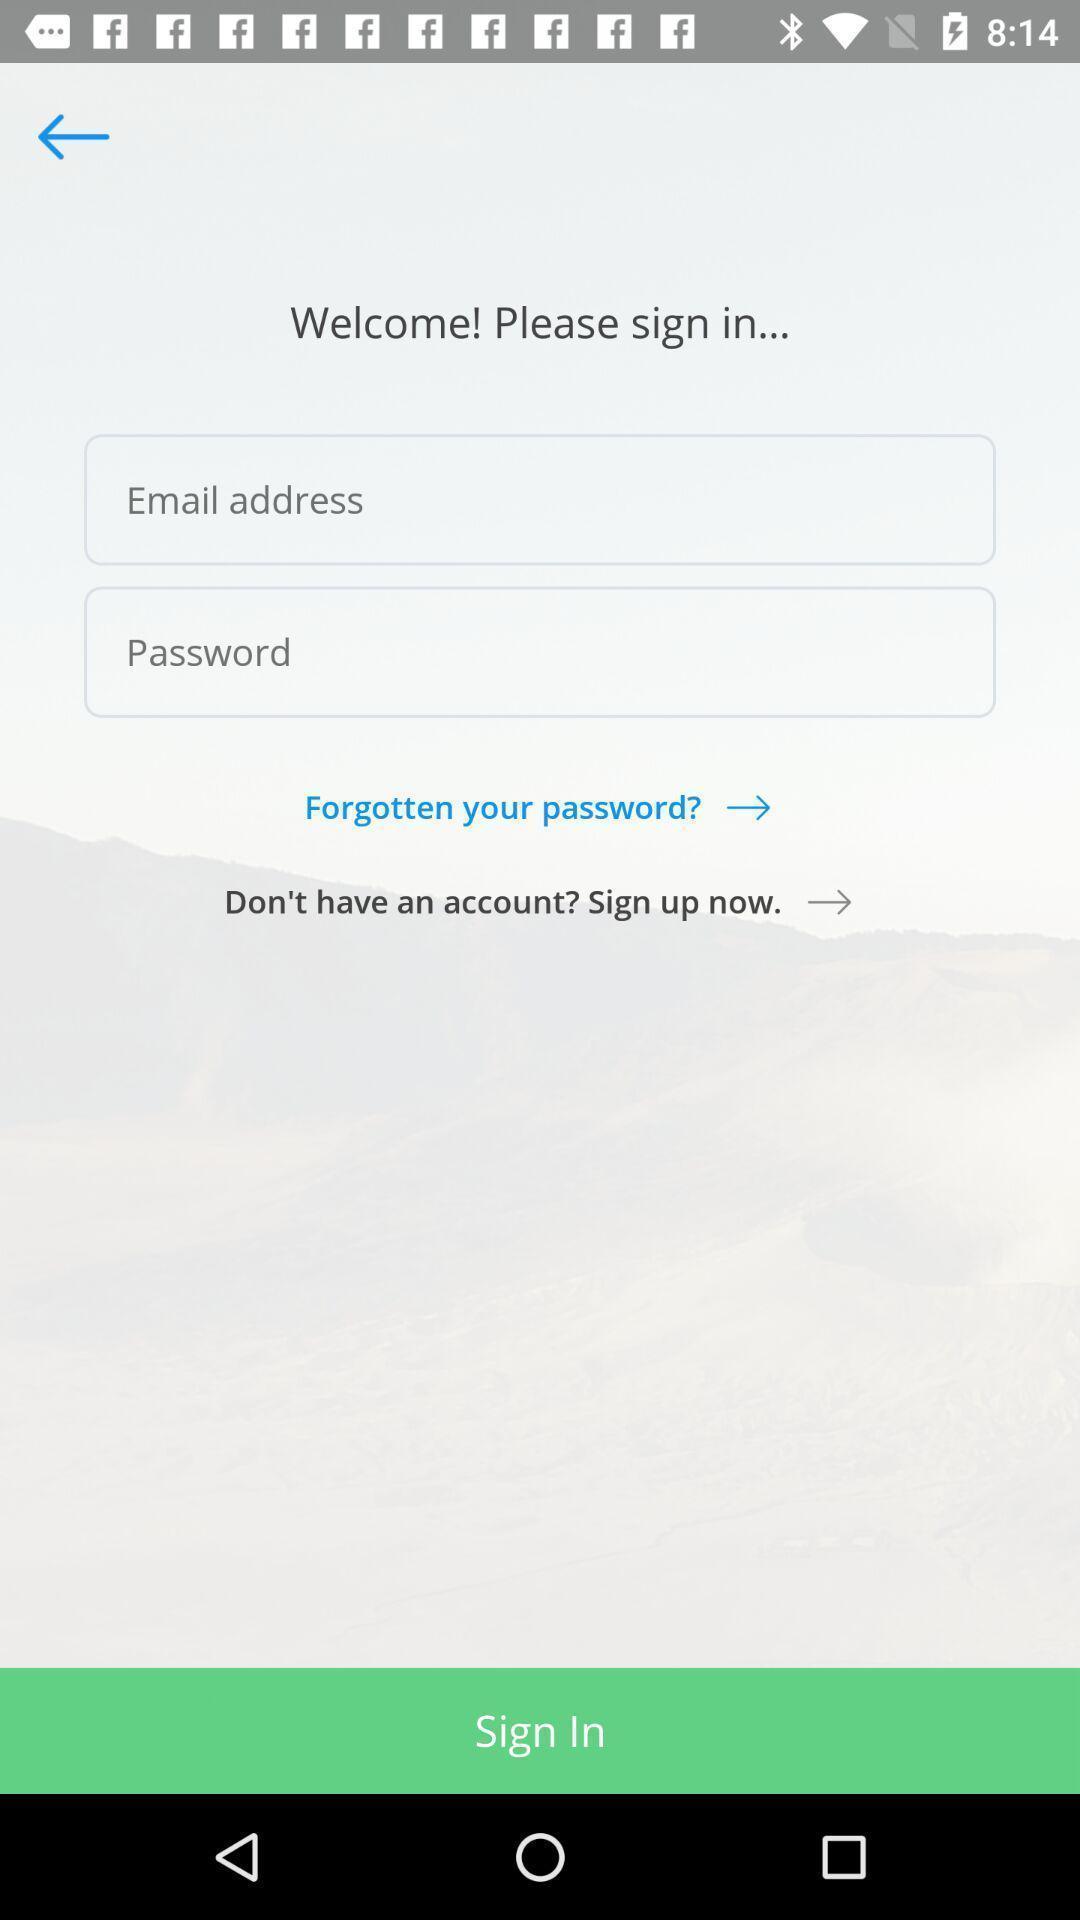Provide a textual representation of this image. Welcome to the sign in page. 